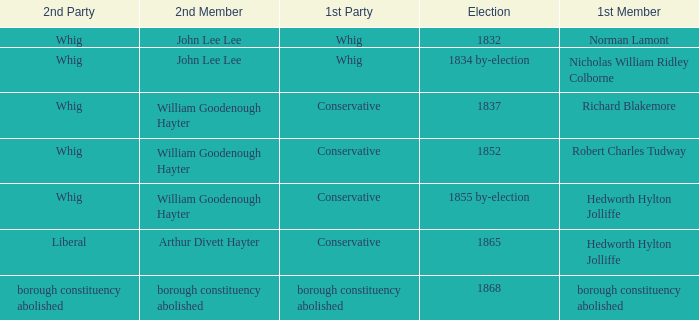Who's the conservative 1st member of the election of 1852? Robert Charles Tudway. 